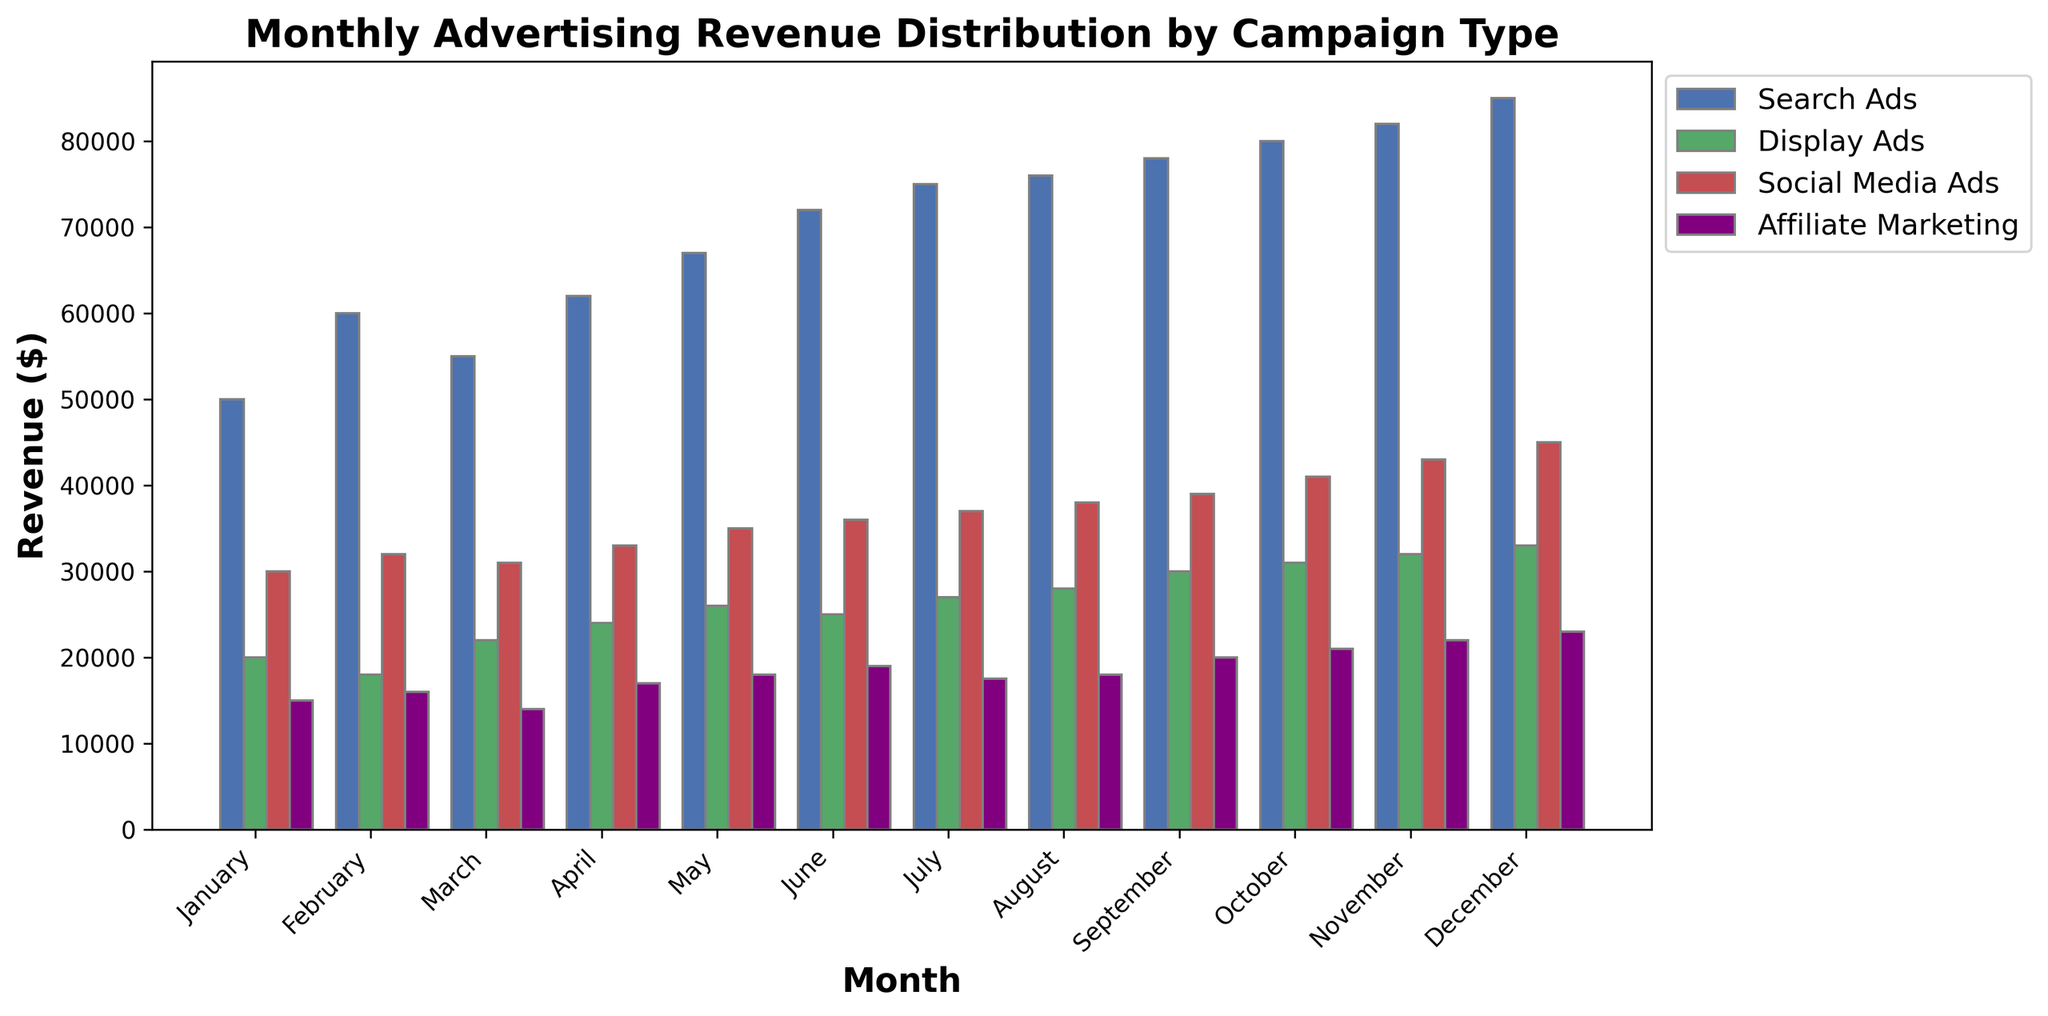Which month had the highest revenue from Search Ads? To find the month with the highest Search Ads revenue, look at the height of the blue bars corresponding to each month. The highest blue bar is in December with $85,000.
Answer: December Which type of advertisement had the lowest revenue in June? To determine the type of advertisement with the lowest revenue in June, compare the heights of the bars in June. Affiliate Marketing, represented by the purple bar, is the shortest with $19,000.
Answer: Affiliate Marketing What is the total revenue from Display Ads for the first quarter (January to March)? To find the total revenue from Display Ads for the first quarter, add the revenue from Display Ads for January ($20,000), February ($18,000), and March ($22,000). The sum is $20,000 + $18,000 + $22,000 = $60,000.
Answer: $60,000 How much more revenue did Social Media Ads generate in December compared to January? Compare the revenue from Social Media Ads in December ($45,000) and January ($30,000). Subtract January's revenue from December's revenue: $45,000 - $30,000 = $15,000.
Answer: $15,000 Which month had the smallest difference between Search Ads and Affiliate Marketing revenue? To find the smallest difference between Search Ads and Affiliate Marketing revenue, calculate the differences for each month and identify the smallest. In January: $50,000 - $15,000 = $35,000, February: $60,000 - $16,000 = $44,000, March: $55,000 - $14,000 = $41,000, April: $62,000 - $17,000 = $45,000, May: $67,000 - $18,000 = $49,000, June: $72,000 - $19,000 = $53,000, July: $75,000 - $17,500 = $57,500, August: $76,000 - $18,000 = $58,000, September: $78,000 - $20,000 = $58,000, October: $80,000 - $21,000 = $59,000, November: $82,000 - $22,000 = $60,000, December: $85,000 - $23,000 = $62,000. January has the smallest difference of $35,000.
Answer: January In which month did Display Ads generate 30% of the total advertising revenue? First, calculate the total revenue for each month and then determine if Display Ads represent 30% of the total. For example, in April, total revenue = $62,000 (Search Ads) + $24,000 (Display Ads) + $33,000 (Social Media Ads) + $17,000 (Affiliate Marketing) = $136,000. 30% of $136,000 = $40,800. April doesn't satisfy the condition. Repeat this for each month. For May, total revenue = $67,000 + $26,000 + $35,000 + $18,000 = $146,000. 30% of $146,000 = $43,800. May also doesn't satisfy the condition. Repeat for all months and find the correct month.
Answer: No month meets the exact condition What is the average monthly revenue for each type of advertisement across the year? To find the average monthly revenue for each advertisement type, sum the revenues for each type across all months and divide by 12. 
- Search Ads: ($50,000 + $60,000 + $55,000 + $62,000 + $67,000 + $72,000 + $75,000 + $76,000 + $78,000 + $80,000 + $82,000 + $85,000) / 12 = $70,583.33
- Display Ads: ($20,000 + $18,000 + $22,000 + $24,000 + $26,000 + $25,000 + $27,000 + $28,000 + $30,000 + $31,000 + $32,000 + $33,000) / 12 = $25,250
- Social Media Ads: ($30,000 + $32,000 + $31,000 + $33,000 + $35,000 + $36,000 + $37,000 + $38,000 + $39,000 + $41,000 + $43,000 + $45,000) / 12 = $36,083.33
- Affiliate Marketing: ($15,000 + $16,000 + $14,000 + $17,000 + $18,000 + $19,000 + $17,500 + $18,000 + $20,000 + $21,000 + $22,000 + $23,000) / 12 = $18,208.33.
Answer: Search Ads: $70,583.33, Display Ads: $25,250, Social Media Ads: $36,083.33, Affiliate Marketing: $18,208.33 